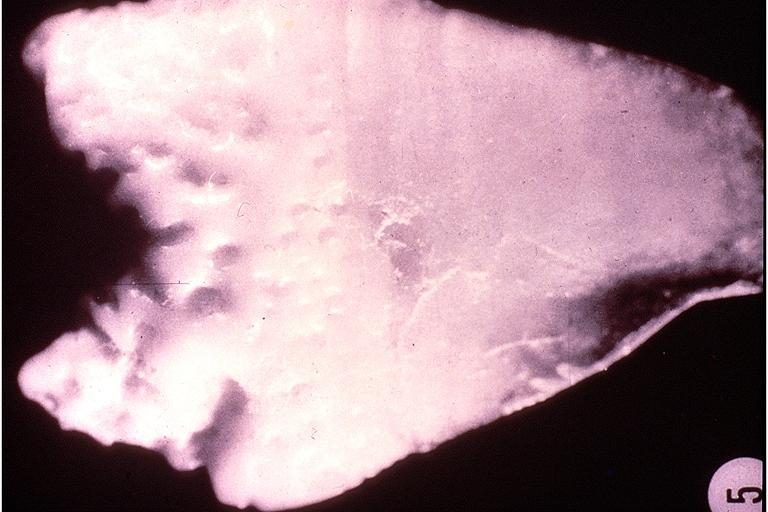s oral present?
Answer the question using a single word or phrase. Yes 